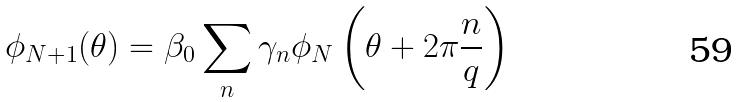<formula> <loc_0><loc_0><loc_500><loc_500>\phi _ { N + 1 } ( \theta ) = \beta _ { 0 } \sum _ { n } \gamma _ { n } \phi _ { N } \left ( \theta + 2 \pi \frac { n } { q } \right )</formula> 